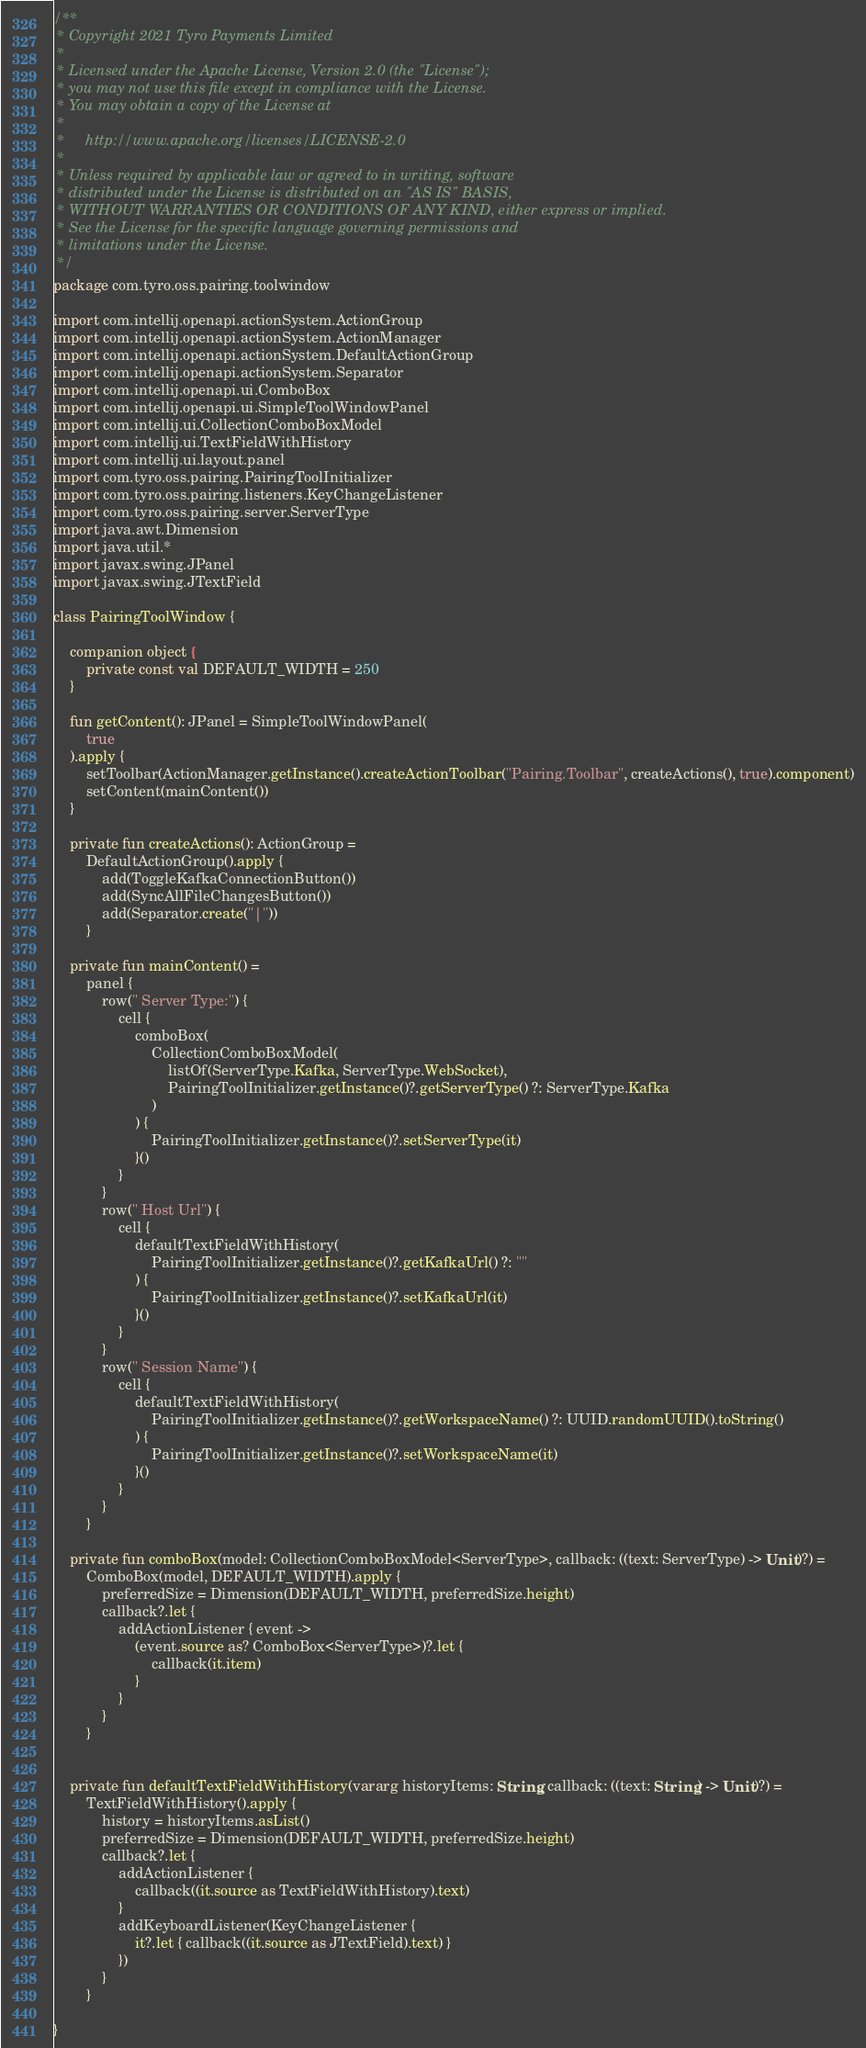<code> <loc_0><loc_0><loc_500><loc_500><_Kotlin_>/**
 * Copyright 2021 Tyro Payments Limited
 *
 * Licensed under the Apache License, Version 2.0 (the "License");
 * you may not use this file except in compliance with the License.
 * You may obtain a copy of the License at
 *
 *     http://www.apache.org/licenses/LICENSE-2.0
 *
 * Unless required by applicable law or agreed to in writing, software
 * distributed under the License is distributed on an "AS IS" BASIS,
 * WITHOUT WARRANTIES OR CONDITIONS OF ANY KIND, either express or implied.
 * See the License for the specific language governing permissions and
 * limitations under the License.
 */
package com.tyro.oss.pairing.toolwindow

import com.intellij.openapi.actionSystem.ActionGroup
import com.intellij.openapi.actionSystem.ActionManager
import com.intellij.openapi.actionSystem.DefaultActionGroup
import com.intellij.openapi.actionSystem.Separator
import com.intellij.openapi.ui.ComboBox
import com.intellij.openapi.ui.SimpleToolWindowPanel
import com.intellij.ui.CollectionComboBoxModel
import com.intellij.ui.TextFieldWithHistory
import com.intellij.ui.layout.panel
import com.tyro.oss.pairing.PairingToolInitializer
import com.tyro.oss.pairing.listeners.KeyChangeListener
import com.tyro.oss.pairing.server.ServerType
import java.awt.Dimension
import java.util.*
import javax.swing.JPanel
import javax.swing.JTextField

class PairingToolWindow {

    companion object {
        private const val DEFAULT_WIDTH = 250
    }

    fun getContent(): JPanel = SimpleToolWindowPanel(
        true
    ).apply {
        setToolbar(ActionManager.getInstance().createActionToolbar("Pairing.Toolbar", createActions(), true).component)
        setContent(mainContent())
    }

    private fun createActions(): ActionGroup =
        DefaultActionGroup().apply {
            add(ToggleKafkaConnectionButton())
            add(SyncAllFileChangesButton())
            add(Separator.create("|"))
        }

    private fun mainContent() =
        panel {
            row(" Server Type:") {
                cell {
                    comboBox(
                        CollectionComboBoxModel(
                            listOf(ServerType.Kafka, ServerType.WebSocket),
                            PairingToolInitializer.getInstance()?.getServerType() ?: ServerType.Kafka
                        )
                    ) {
                        PairingToolInitializer.getInstance()?.setServerType(it)
                    }()
                }
            }
            row(" Host Url") {
                cell {
                    defaultTextFieldWithHistory(
                        PairingToolInitializer.getInstance()?.getKafkaUrl() ?: ""
                    ) {
                        PairingToolInitializer.getInstance()?.setKafkaUrl(it)
                    }()
                }
            }
            row(" Session Name") {
                cell {
                    defaultTextFieldWithHistory(
                        PairingToolInitializer.getInstance()?.getWorkspaceName() ?: UUID.randomUUID().toString()
                    ) {
                        PairingToolInitializer.getInstance()?.setWorkspaceName(it)
                    }()
                }
            }
        }

    private fun comboBox(model: CollectionComboBoxModel<ServerType>, callback: ((text: ServerType) -> Unit)?) =
        ComboBox(model, DEFAULT_WIDTH).apply {
            preferredSize = Dimension(DEFAULT_WIDTH, preferredSize.height)
            callback?.let {
                addActionListener { event ->
                    (event.source as? ComboBox<ServerType>)?.let {
                        callback(it.item)
                    }
                }
            }
        }


    private fun defaultTextFieldWithHistory(vararg historyItems: String, callback: ((text: String) -> Unit)?) =
        TextFieldWithHistory().apply {
            history = historyItems.asList()
            preferredSize = Dimension(DEFAULT_WIDTH, preferredSize.height)
            callback?.let {
                addActionListener {
                    callback((it.source as TextFieldWithHistory).text)
                }
                addKeyboardListener(KeyChangeListener {
                    it?.let { callback((it.source as JTextField).text) }
                })
            }
        }

}
</code> 